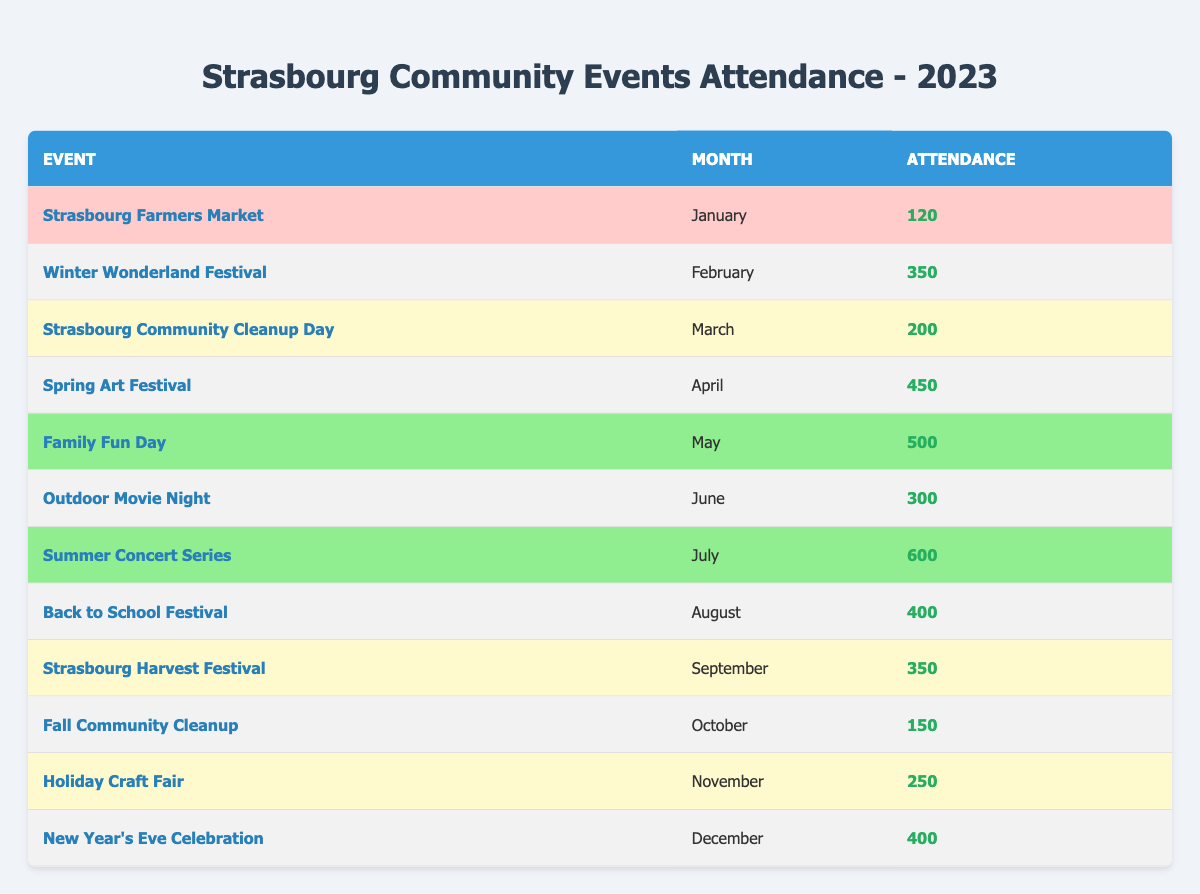What was the attendance for the Family Fun Day event? The Family Fun Day event took place in May 2023 and has an attendance of 500. This value is directly stated in the table under the corresponding event.
Answer: 500 Which month had the highest attendance for community events? The month of July had the highest attendance, with the Summer Concert Series attracting 600 participants. This attendance value is noted in the table.
Answer: July How many events had low attendance? There are two events that had low attendance: the Strasbourg Farmers Market in January (120) and the Fall Community Cleanup in October (150). Both events are indicated with a low highlight in the table.
Answer: 2 What is the average attendance for the events marked as high? The events with high attendance are the Spring Art Festival (450), Family Fun Day (500), Summer Concert Series (600), Back to School Festival (400), and New Year's Eve Celebration (400). Adding these together (450 + 500 + 600 + 400 + 400) equals 2350. There are 5 events, so the average is 2350/5 = 470.
Answer: 470 Was there a month with medium attended events only? No, there was no month where all events had medium attendance as there are months with high and low events as well. For example, June has a medium event while July has a high event.
Answer: No Which event had the lowest attendance overall? The event with the lowest attendance overall is the Strasbourg Farmers Market in January, which had an attendance of 120. This value is directly shown in the table.
Answer: Strasbourg Farmers Market How many more people attended the Summer Concert Series than the Fall Community Cleanup? The Summer Concert Series had an attendance of 600 while the Fall Community Cleanup had an attendance of 150. The difference is calculated by subtracting the lower number from the higher one: 600 - 150 = 450.
Answer: 450 In which month was the attendance closest to 300? The Outdoor Movie Night in June had an attendance of 300, which is exactly that number. Additionally, the Winter Wonderland Festival in February had 350, which is close but not equal. Hence, June is the month where attendance was exactly 300.
Answer: June How many events had a medium attendance, and what percentage does that represent of total events? There are 5 events with medium attendance: Winter Wonderland Festival, Community Cleanup Day, Outdoor Movie Night, Strasbourg Harvest Festival, and Holiday Craft Fair. With a total of 12 events, the percentage is calculated by (5/12) * 100 = 41.67%.
Answer: 41.67% Which event had the same attendance as the Holiday Craft Fair and which month was it held? The Holiday Craft Fair had an attendance of 250, and no other event in the table shares this exact attendance figure, making it unique. Therefore, there is no event with the same attendance.
Answer: None 